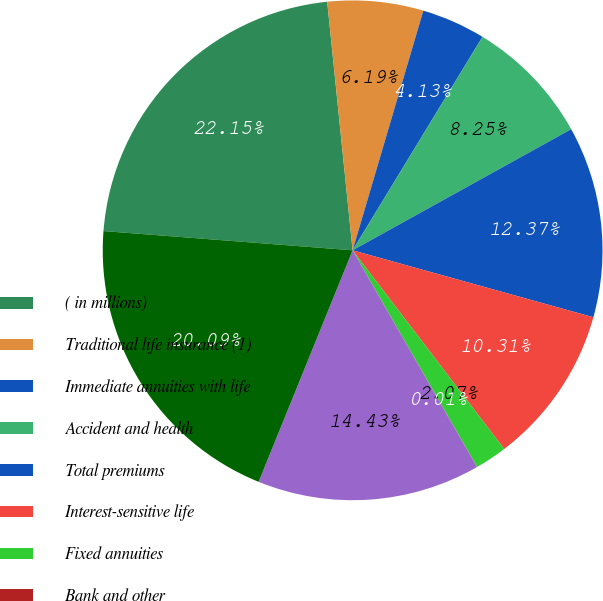Convert chart to OTSL. <chart><loc_0><loc_0><loc_500><loc_500><pie_chart><fcel>( in millions)<fcel>Traditional life insurance (1)<fcel>Immediate annuities with life<fcel>Accident and health<fcel>Total premiums<fcel>Interest-sensitive life<fcel>Fixed annuities<fcel>Bank and other<fcel>Total contract charges (2)<fcel>Life and annuity premiums and<nl><fcel>22.15%<fcel>6.19%<fcel>4.13%<fcel>8.25%<fcel>12.37%<fcel>10.31%<fcel>2.07%<fcel>0.01%<fcel>14.43%<fcel>20.09%<nl></chart> 